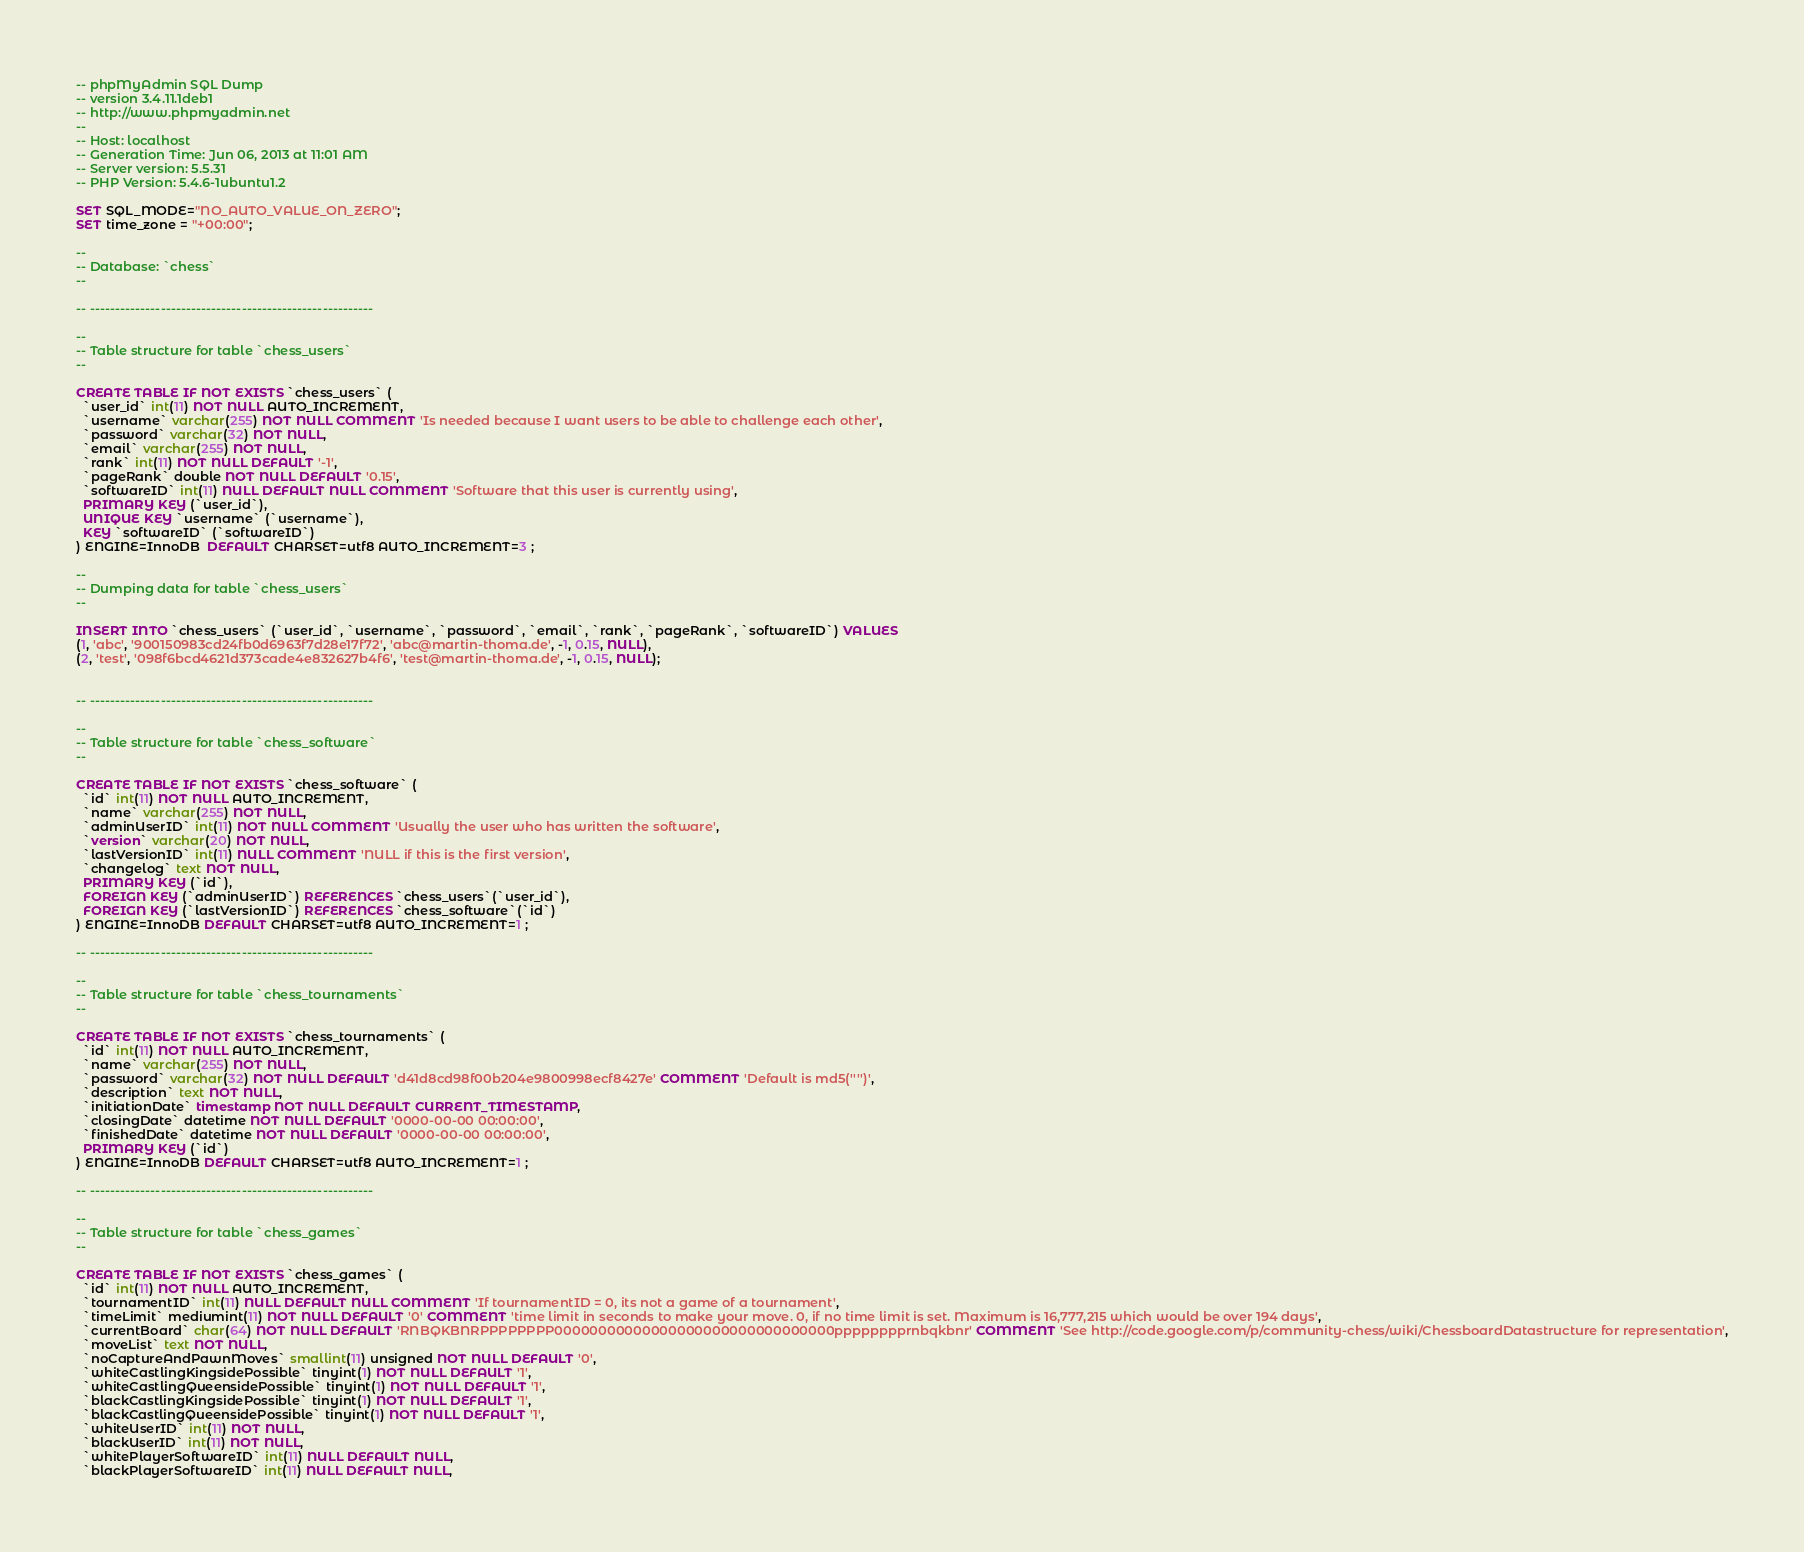Convert code to text. <code><loc_0><loc_0><loc_500><loc_500><_SQL_>-- phpMyAdmin SQL Dump
-- version 3.4.11.1deb1
-- http://www.phpmyadmin.net
--
-- Host: localhost
-- Generation Time: Jun 06, 2013 at 11:01 AM
-- Server version: 5.5.31
-- PHP Version: 5.4.6-1ubuntu1.2

SET SQL_MODE="NO_AUTO_VALUE_ON_ZERO";
SET time_zone = "+00:00";

--
-- Database: `chess`
--

-- --------------------------------------------------------

--
-- Table structure for table `chess_users`
--

CREATE TABLE IF NOT EXISTS `chess_users` (
  `user_id` int(11) NOT NULL AUTO_INCREMENT,
  `username` varchar(255) NOT NULL COMMENT 'Is needed because I want users to be able to challenge each other',
  `password` varchar(32) NOT NULL,
  `email` varchar(255) NOT NULL,
  `rank` int(11) NOT NULL DEFAULT '-1',
  `pageRank` double NOT NULL DEFAULT '0.15',
  `softwareID` int(11) NULL DEFAULT NULL COMMENT 'Software that this user is currently using',
  PRIMARY KEY (`user_id`),
  UNIQUE KEY `username` (`username`),
  KEY `softwareID` (`softwareID`)
) ENGINE=InnoDB  DEFAULT CHARSET=utf8 AUTO_INCREMENT=3 ;

--
-- Dumping data for table `chess_users`
--

INSERT INTO `chess_users` (`user_id`, `username`, `password`, `email`, `rank`, `pageRank`, `softwareID`) VALUES
(1, 'abc', '900150983cd24fb0d6963f7d28e17f72', 'abc@martin-thoma.de', -1, 0.15, NULL),
(2, 'test', '098f6bcd4621d373cade4e832627b4f6', 'test@martin-thoma.de', -1, 0.15, NULL);


-- --------------------------------------------------------

--
-- Table structure for table `chess_software`
--

CREATE TABLE IF NOT EXISTS `chess_software` (
  `id` int(11) NOT NULL AUTO_INCREMENT,
  `name` varchar(255) NOT NULL,
  `adminUserID` int(11) NOT NULL COMMENT 'Usually the user who has written the software',
  `version` varchar(20) NOT NULL,
  `lastVersionID` int(11) NULL COMMENT 'NULL if this is the first version',
  `changelog` text NOT NULL,
  PRIMARY KEY (`id`),
  FOREIGN KEY (`adminUserID`) REFERENCES `chess_users`(`user_id`),
  FOREIGN KEY (`lastVersionID`) REFERENCES `chess_software`(`id`)
) ENGINE=InnoDB DEFAULT CHARSET=utf8 AUTO_INCREMENT=1 ;

-- --------------------------------------------------------

--
-- Table structure for table `chess_tournaments`
--

CREATE TABLE IF NOT EXISTS `chess_tournaments` (
  `id` int(11) NOT NULL AUTO_INCREMENT,
  `name` varchar(255) NOT NULL,
  `password` varchar(32) NOT NULL DEFAULT 'd41d8cd98f00b204e9800998ecf8427e' COMMENT 'Default is md5('''')',
  `description` text NOT NULL,
  `initiationDate` timestamp NOT NULL DEFAULT CURRENT_TIMESTAMP,
  `closingDate` datetime NOT NULL DEFAULT '0000-00-00 00:00:00',
  `finishedDate` datetime NOT NULL DEFAULT '0000-00-00 00:00:00',
  PRIMARY KEY (`id`)
) ENGINE=InnoDB DEFAULT CHARSET=utf8 AUTO_INCREMENT=1 ;

-- --------------------------------------------------------

--
-- Table structure for table `chess_games`
--

CREATE TABLE IF NOT EXISTS `chess_games` (
  `id` int(11) NOT NULL AUTO_INCREMENT,
  `tournamentID` int(11) NULL DEFAULT NULL COMMENT 'If tournamentID = 0, its not a game of a tournament',
  `timeLimit` mediumint(11) NOT NULL DEFAULT '0' COMMENT 'time limit in seconds to make your move. 0, if no time limit is set. Maximum is 16,777,215 which would be over 194 days',
  `currentBoard` char(64) NOT NULL DEFAULT 'RNBQKBNRPPPPPPPP00000000000000000000000000000000pppppppprnbqkbnr' COMMENT 'See http://code.google.com/p/community-chess/wiki/ChessboardDatastructure for representation',
  `moveList` text NOT NULL,
  `noCaptureAndPawnMoves` smallint(11) unsigned NOT NULL DEFAULT '0',
  `whiteCastlingKingsidePossible` tinyint(1) NOT NULL DEFAULT '1',
  `whiteCastlingQueensidePossible` tinyint(1) NOT NULL DEFAULT '1',
  `blackCastlingKingsidePossible` tinyint(1) NOT NULL DEFAULT '1',
  `blackCastlingQueensidePossible` tinyint(1) NOT NULL DEFAULT '1',
  `whiteUserID` int(11) NOT NULL,
  `blackUserID` int(11) NOT NULL,
  `whitePlayerSoftwareID` int(11) NULL DEFAULT NULL,
  `blackPlayerSoftwareID` int(11) NULL DEFAULT NULL,</code> 